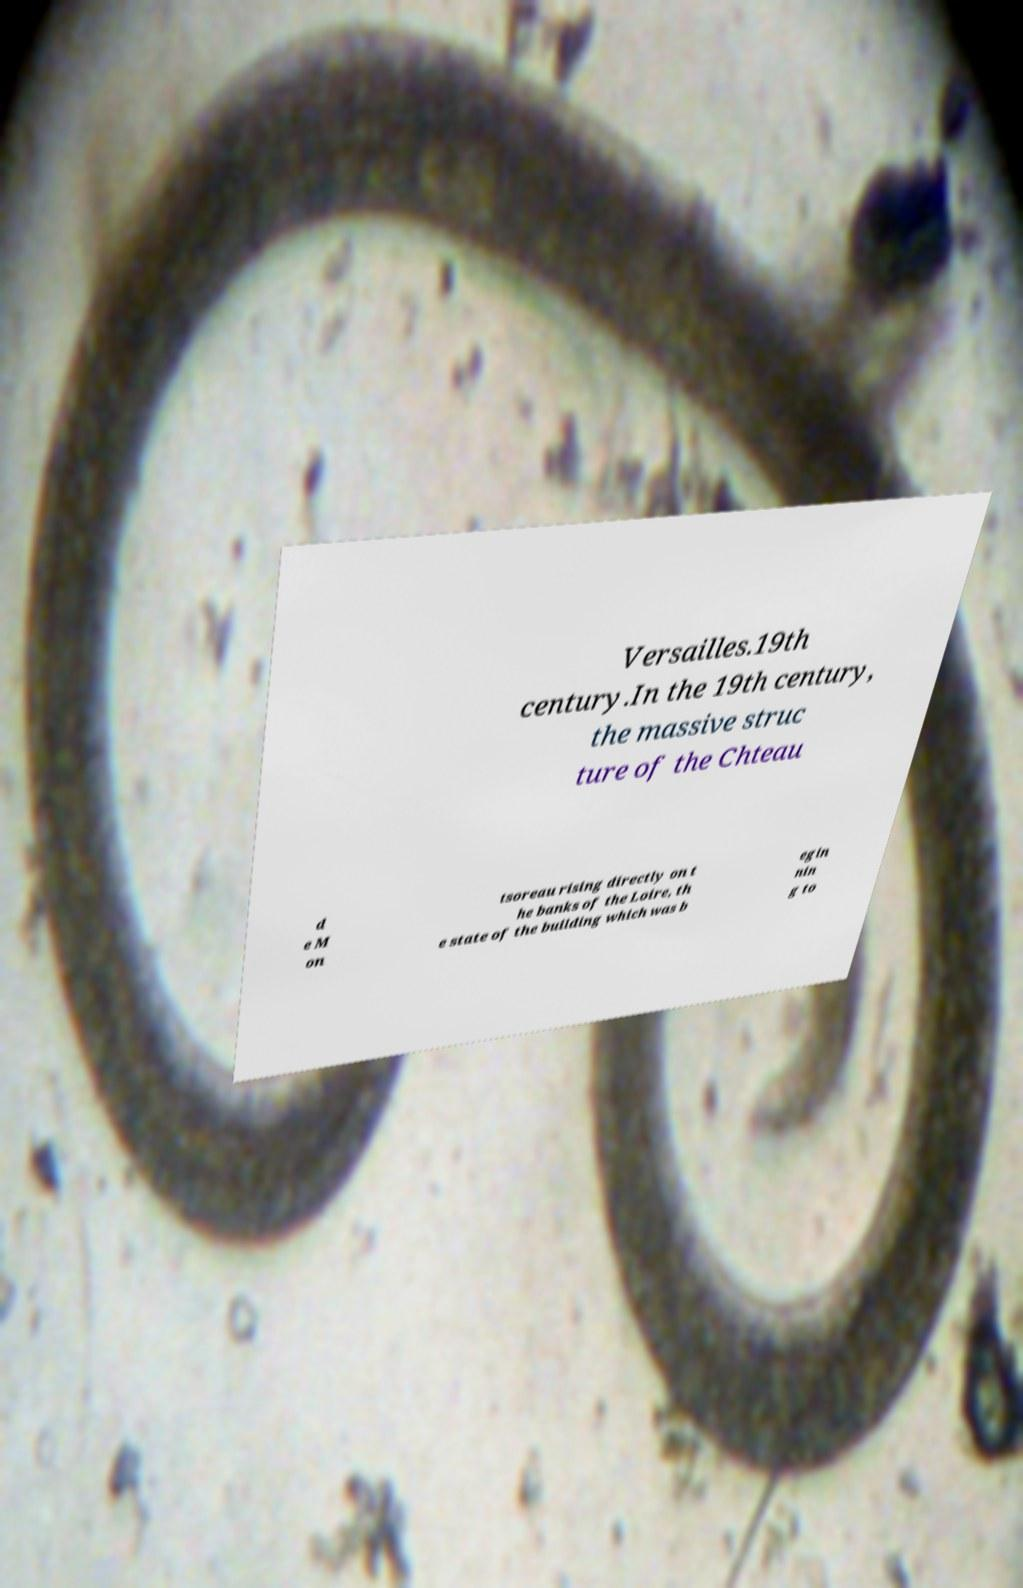Can you read and provide the text displayed in the image?This photo seems to have some interesting text. Can you extract and type it out for me? Versailles.19th century.In the 19th century, the massive struc ture of the Chteau d e M on tsoreau rising directly on t he banks of the Loire, th e state of the building which was b egin nin g to 